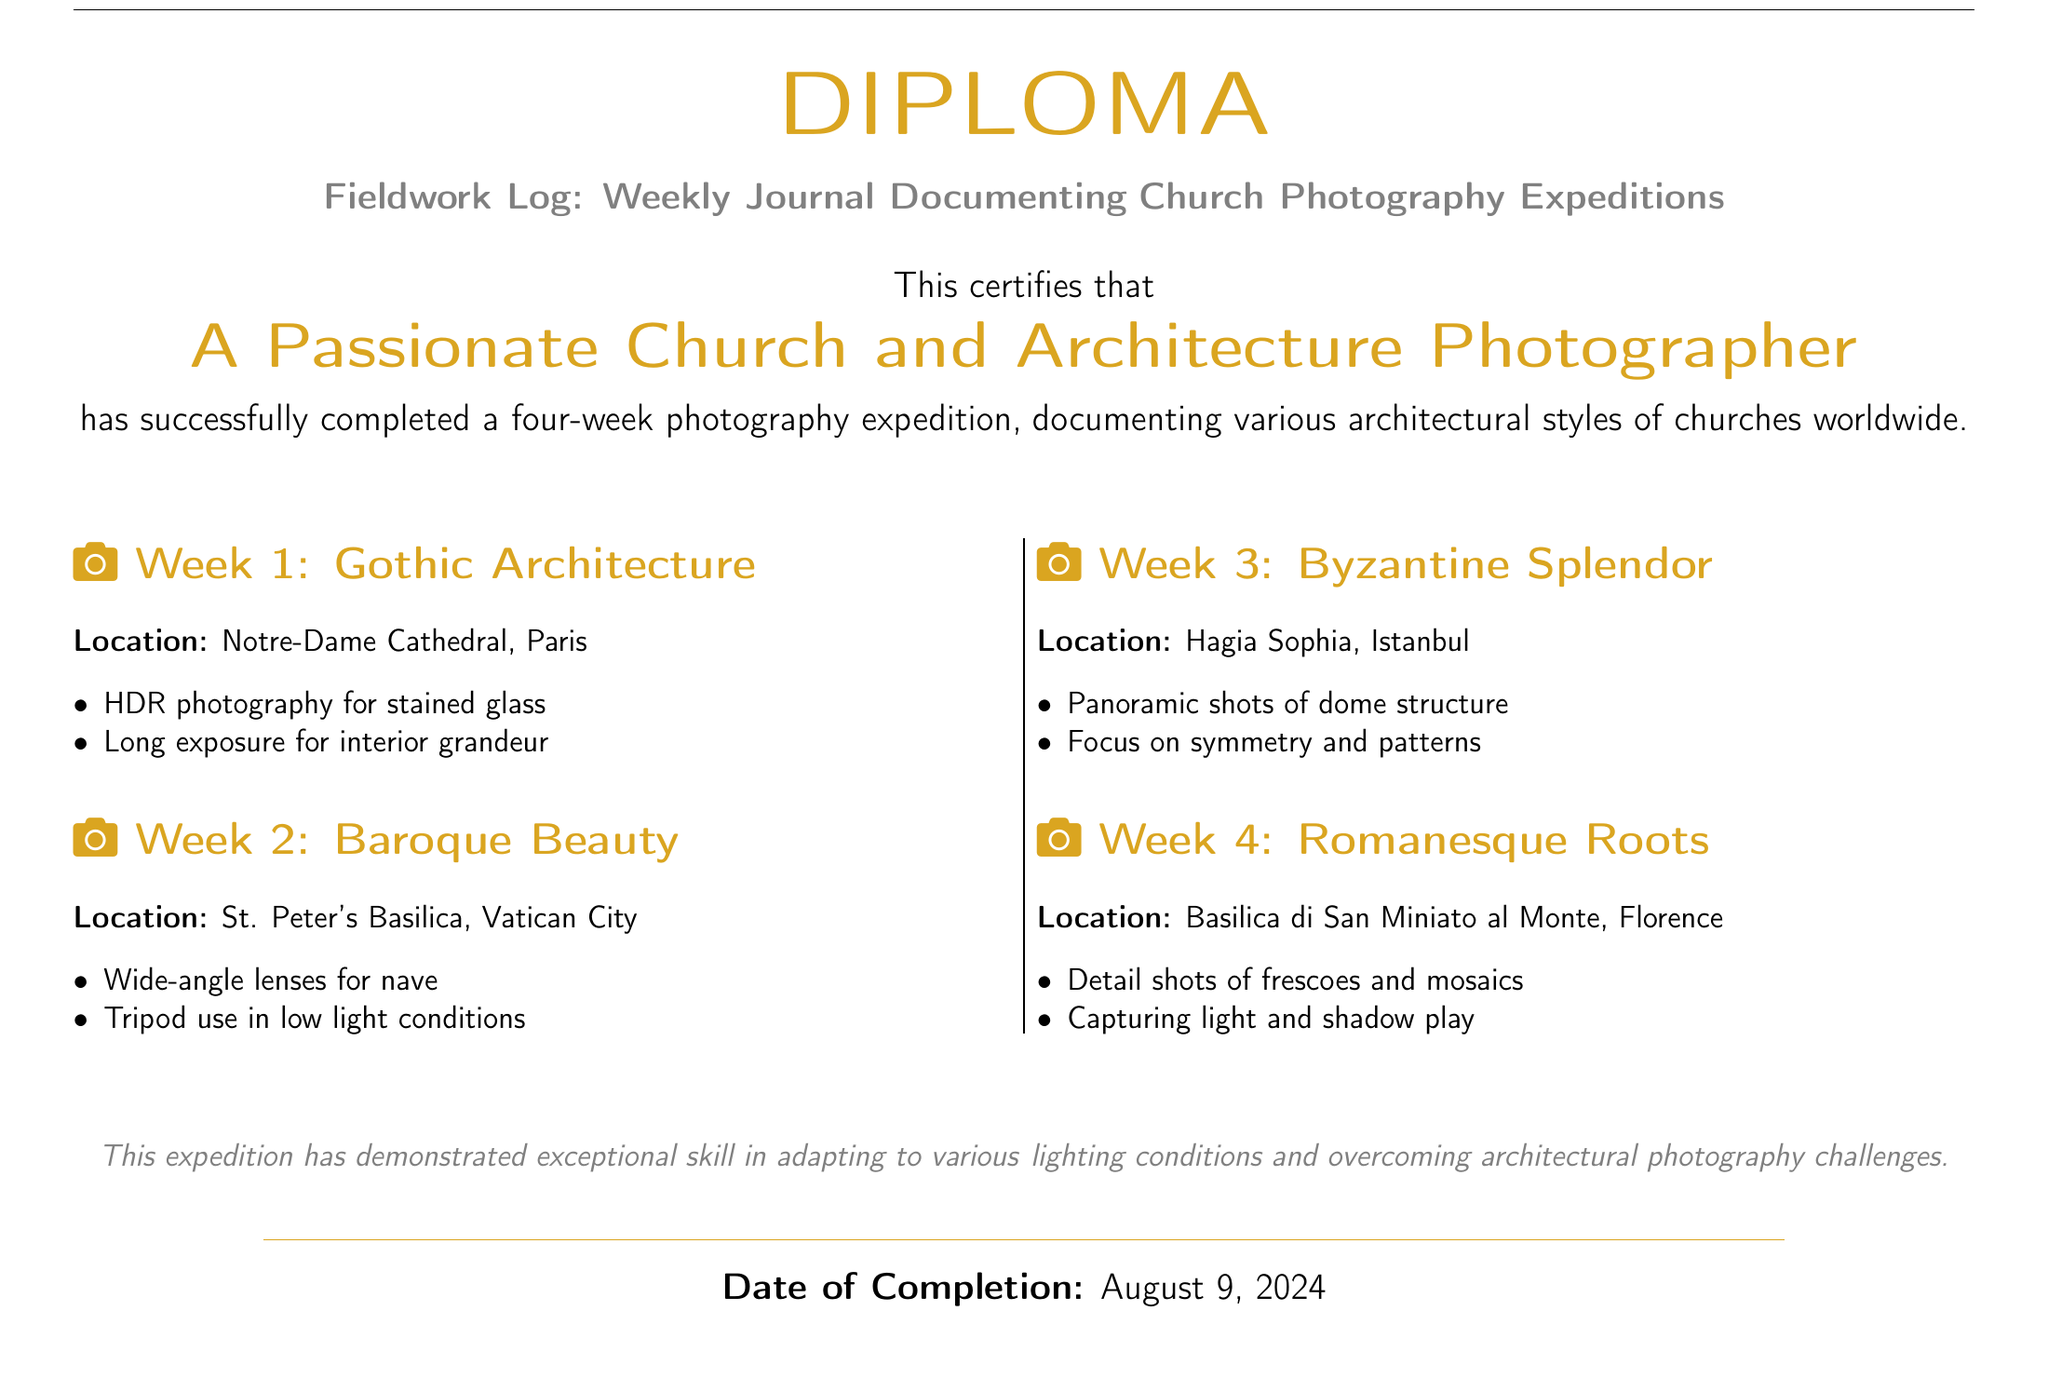What is the title of the diploma? The title is prominently displayed in the document, indicating the focus of the log is on church photography and expeditions.
Answer: Fieldwork Log: Weekly Journal Documenting Church Photography Expeditions Who is the recipient of the diploma? The name of the person who completed the photography expedition is stated in the document.
Answer: A Passionate Church and Architecture Photographer How many weeks did the photography expedition last? The document clearly outlines the weeks of the expedition, indicating its duration.
Answer: Four weeks What location was documented in Week 2? Each week's section specifies the location visited for photography, particularly in Week 2.
Answer: St. Peter's Basilica, Vatican City What photography technique was used for stained glass in Week 1? The techniques used for each week are listed as bullet points, specifically for Week 1’s focus on stained glass.
Answer: HDR photography Which architectural style was featured in Week 3? The document categorizes each week by the architectural style being documented, providing clarity on the focus.
Answer: Byzantine What kind of shots were emphasized in Week 4? The document provides specific details about the types of shots taken during each week’s expedition.
Answer: Detail shots What color is associated with the title of the diploma? The color used for the title is explicitly noted in the document's formatting.
Answer: Church gold What does the document indicate about the expedition’s skill in photography? The concluding remarks comment on the participant’s abilities demonstrated during the expedition.
Answer: Exceptional skill 